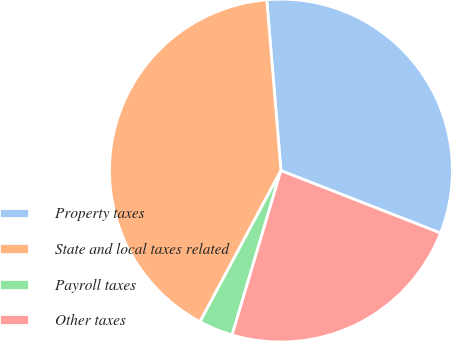Convert chart. <chart><loc_0><loc_0><loc_500><loc_500><pie_chart><fcel>Property taxes<fcel>State and local taxes related<fcel>Payroll taxes<fcel>Other taxes<nl><fcel>32.26%<fcel>40.86%<fcel>3.23%<fcel>23.66%<nl></chart> 